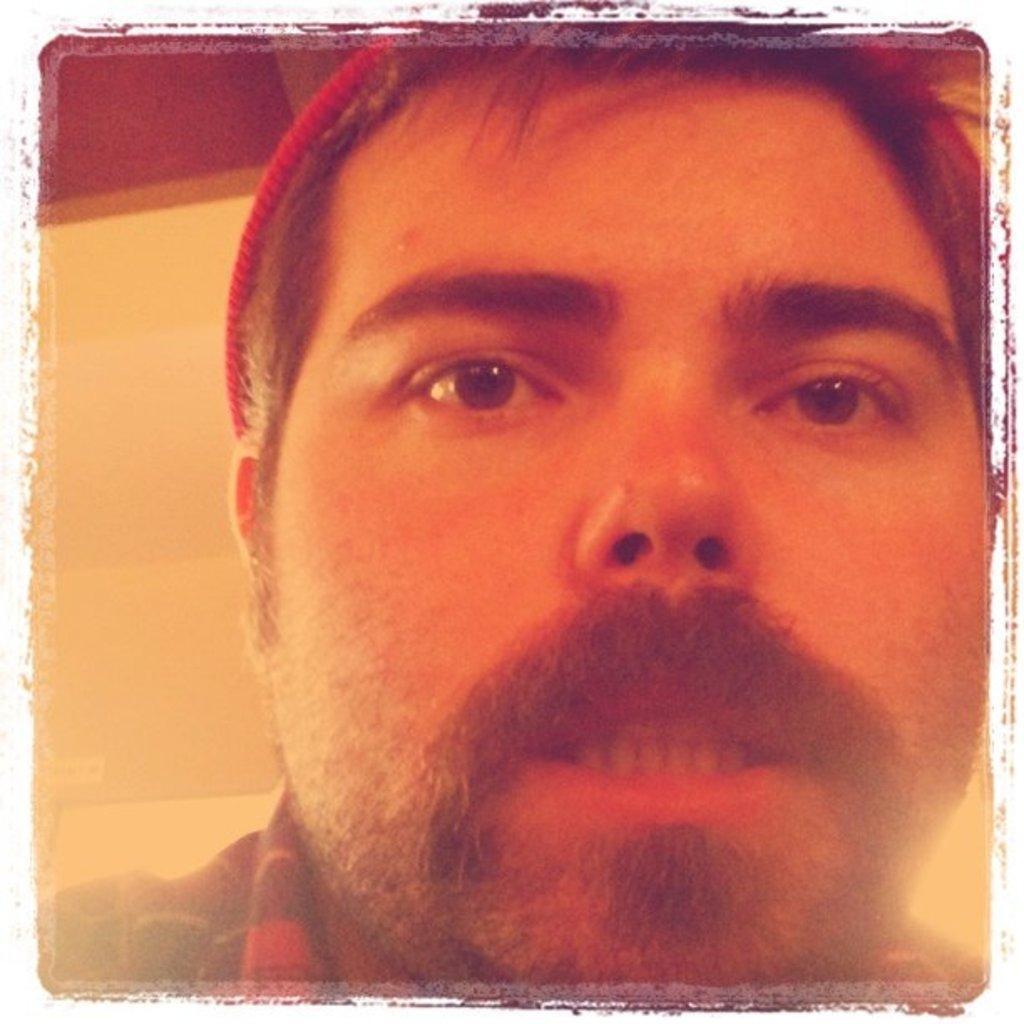In one or two sentences, can you explain what this image depicts? In this image there is a person's face, behind him there is a wall. 